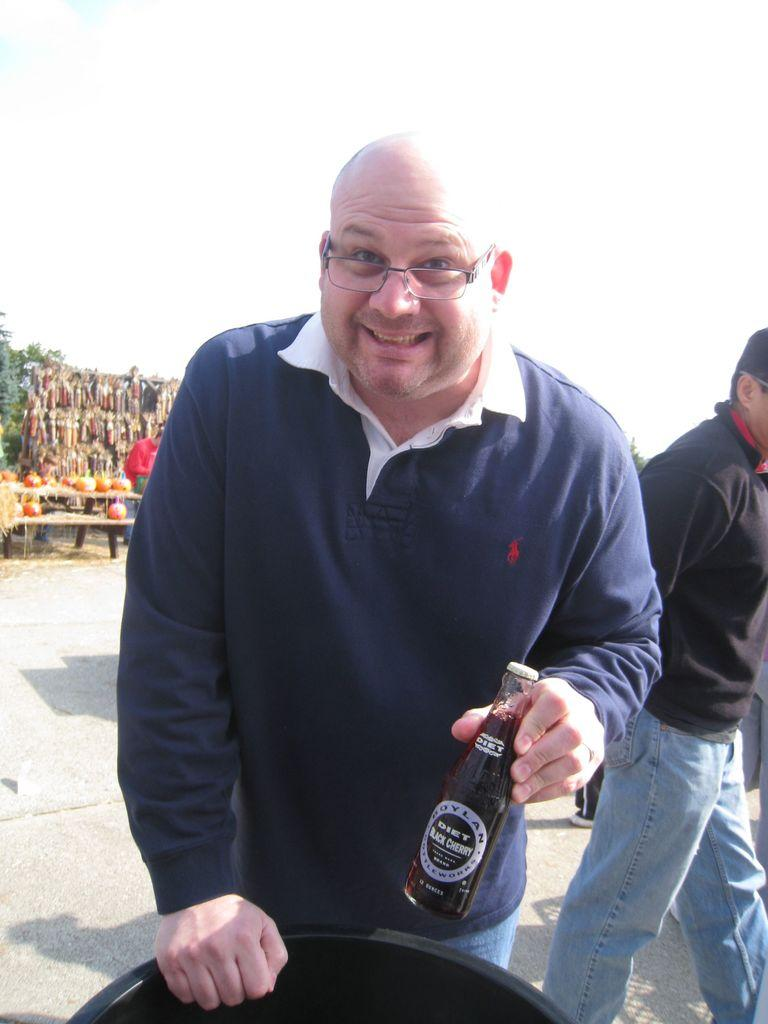What is the person in the image doing? The person is standing and holding a bottle in the image. Can you describe the other person in the image? There is another person in the background of the image. What objects are on the table in the image? There are pumpkins on a table in the image. What type of robin is attacking the person holding the bottle in the image? There is no robin present in the image, nor is there any attack taking place. 